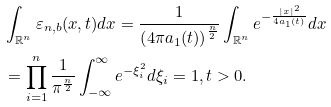Convert formula to latex. <formula><loc_0><loc_0><loc_500><loc_500>& \int _ { \mathbb { R } ^ { n } } \varepsilon _ { n , b } ( x , t ) d x = \frac { 1 } { \left ( 4 \pi a _ { 1 } ( t ) \right ) ^ { \frac { n } { 2 } } } \int _ { \mathbb { R } ^ { n } } e ^ { - \frac { | x | ^ { 2 } } { 4 a _ { 1 } ( t ) } } d x \\ & = \prod _ { i = 1 } ^ { n } \frac { 1 } { \pi ^ { \frac { n } { 2 } } } \int _ { - \infty } ^ { \infty } e ^ { - \xi _ { i } ^ { 2 } } d \xi _ { i } = 1 , t > 0 .</formula> 